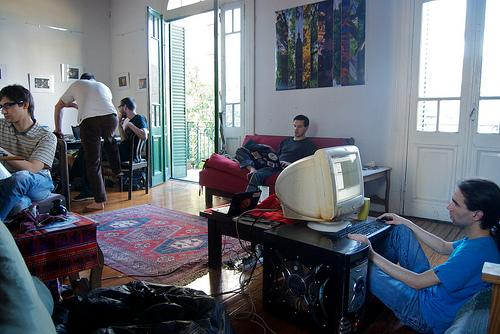Which type of flooring can be seen in the image? Wood flooring is visible underneath the rugs. Explain the location of the green door in the image. The green door with windows is located to the left side of the picture hanging on the wall. For the referential expression grounding task, describe a man's action near the green door. A man near the green door is standing with his right foot on a chair. For the multi-choice VQA task, pick the right option: What is the man doing while seated at the computer? A) Eating B) Looking at the monitor C) Sleeping B) Looking at the monitor In the image, what can you see hanging on the wall? There's a picture and four framed square pictures hanging on the wall. In the product advertisement task, promote the furniture in the image by highlighting its features. Upgrade your living space with our elegant dark brown wood table and cozy red couch. Complement your setting with our beautiful multicolored area rug, creating a warm and inviting atmosphere. For the visual entailment task, state one true sentence about the objects on the floor. There is a multicolored area rug and a red oriental rug on the floor. What color and type of shirt is one of the men in the image wearing? One of the men is wearing a blue short-sleeved shirt. Point out where the sunlight can be seen in the image. There's a glow of sunlight coming through the windows. Identify the type of electronic device on the table in the image. A white computer monitor is sitting on the table. 